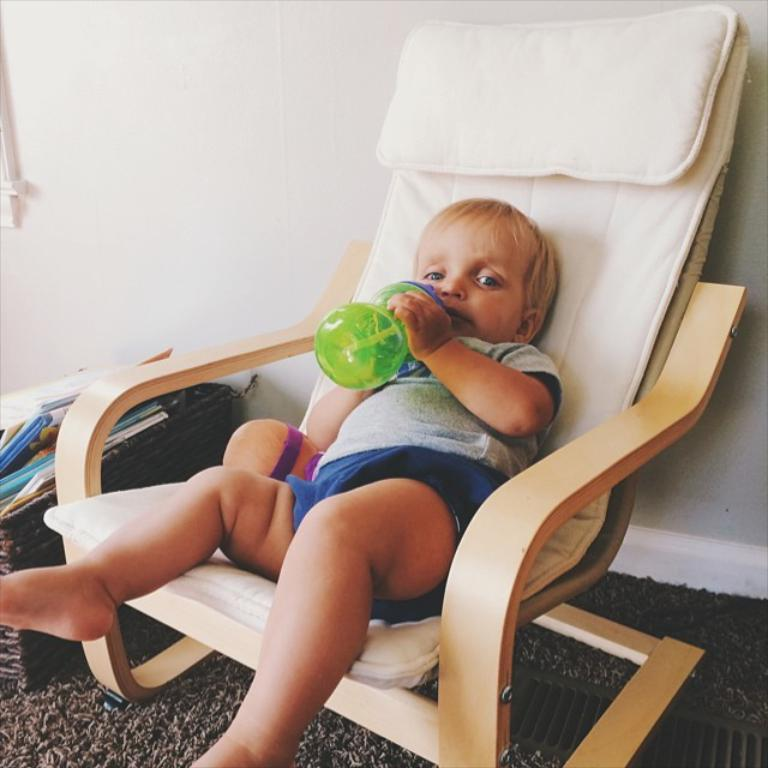What is the main subject of the image? The main subject of the image is a kid. What is the kid doing in the image? The kid is sitting on a chair in the image. What is the kid holding in his hand? The kid is holding a sipper in his hand. What type of knife is the kid using to cut the rod in the image? There is no knife or rod present in the image; the kid is holding a sipper. 